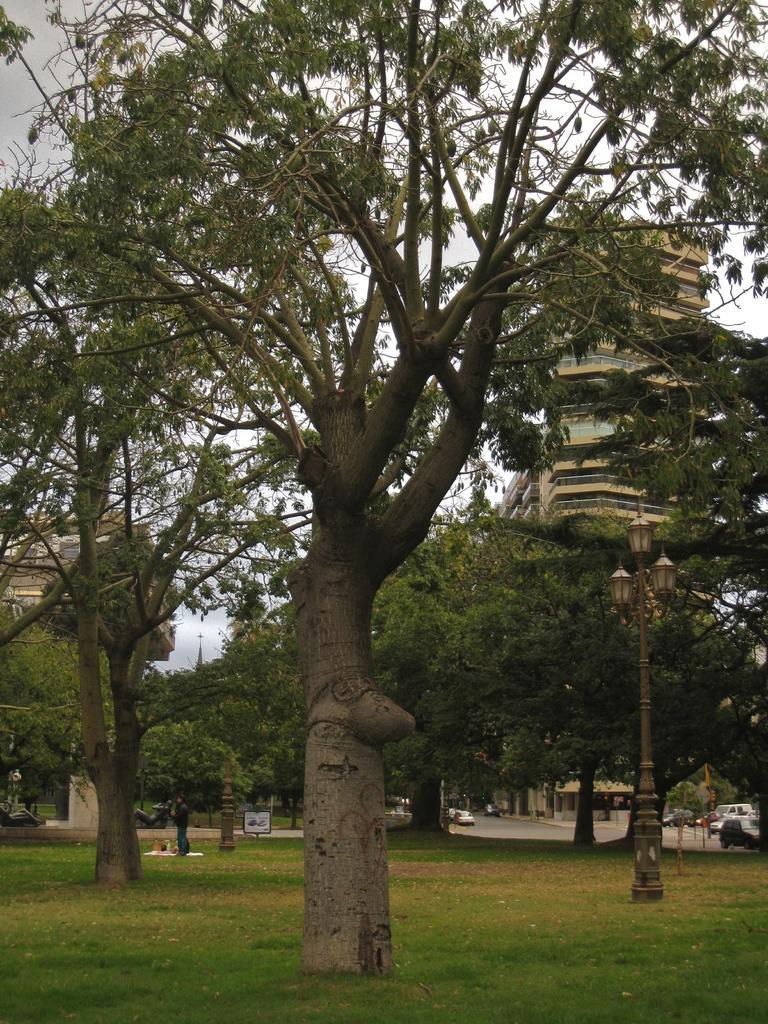In one or two sentences, can you explain what this image depicts? As we can see in the image there is grass, trees buildings, street lamp and vehicles. On the top there is sky. 